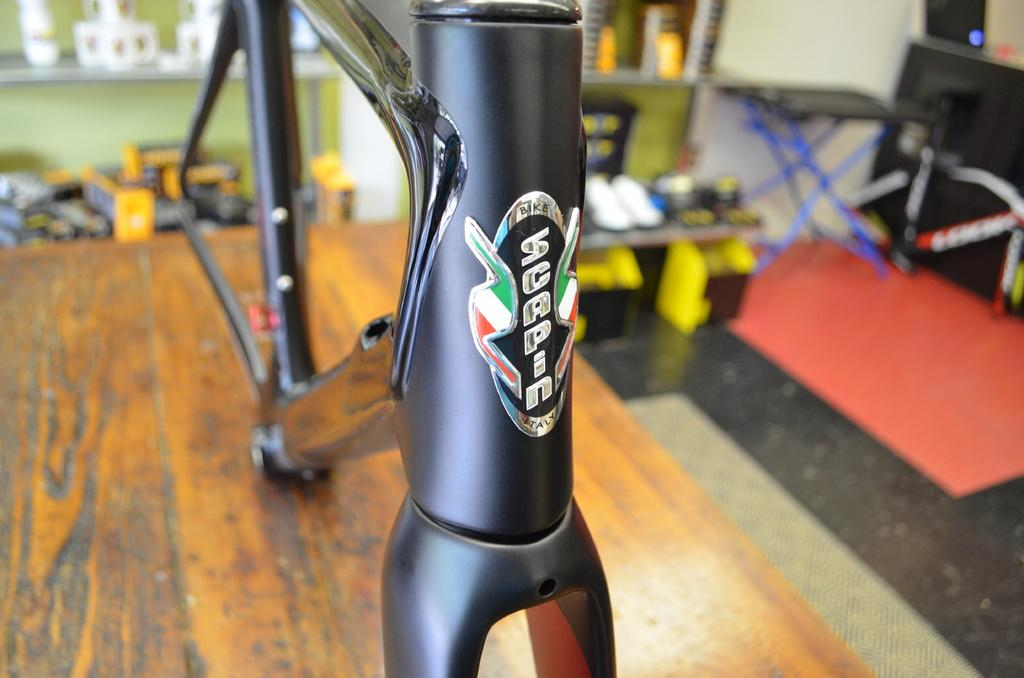What type of furniture is present in the image? There is a table in the image. What is placed on the table? There is a metal object on the table. What can be seen in the background of the image? There is a rack in the background of the image. What is on the rack? There are items on the rack. Can you describe the arrangement of the furniture in the image? There is another table beside the rack. How does the representative use the metal object to make a payment in the image? There is no representative or payment activity present in the image; it only features a table, a metal object, a rack, and items on the rack. 